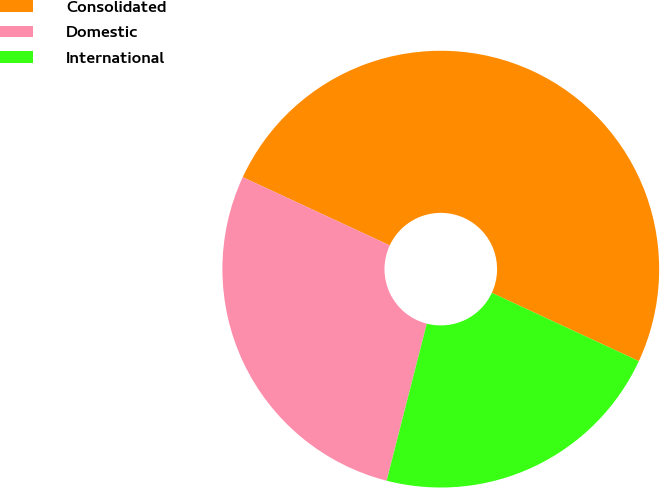Convert chart to OTSL. <chart><loc_0><loc_0><loc_500><loc_500><pie_chart><fcel>Consolidated<fcel>Domestic<fcel>International<nl><fcel>50.0%<fcel>27.93%<fcel>22.07%<nl></chart> 